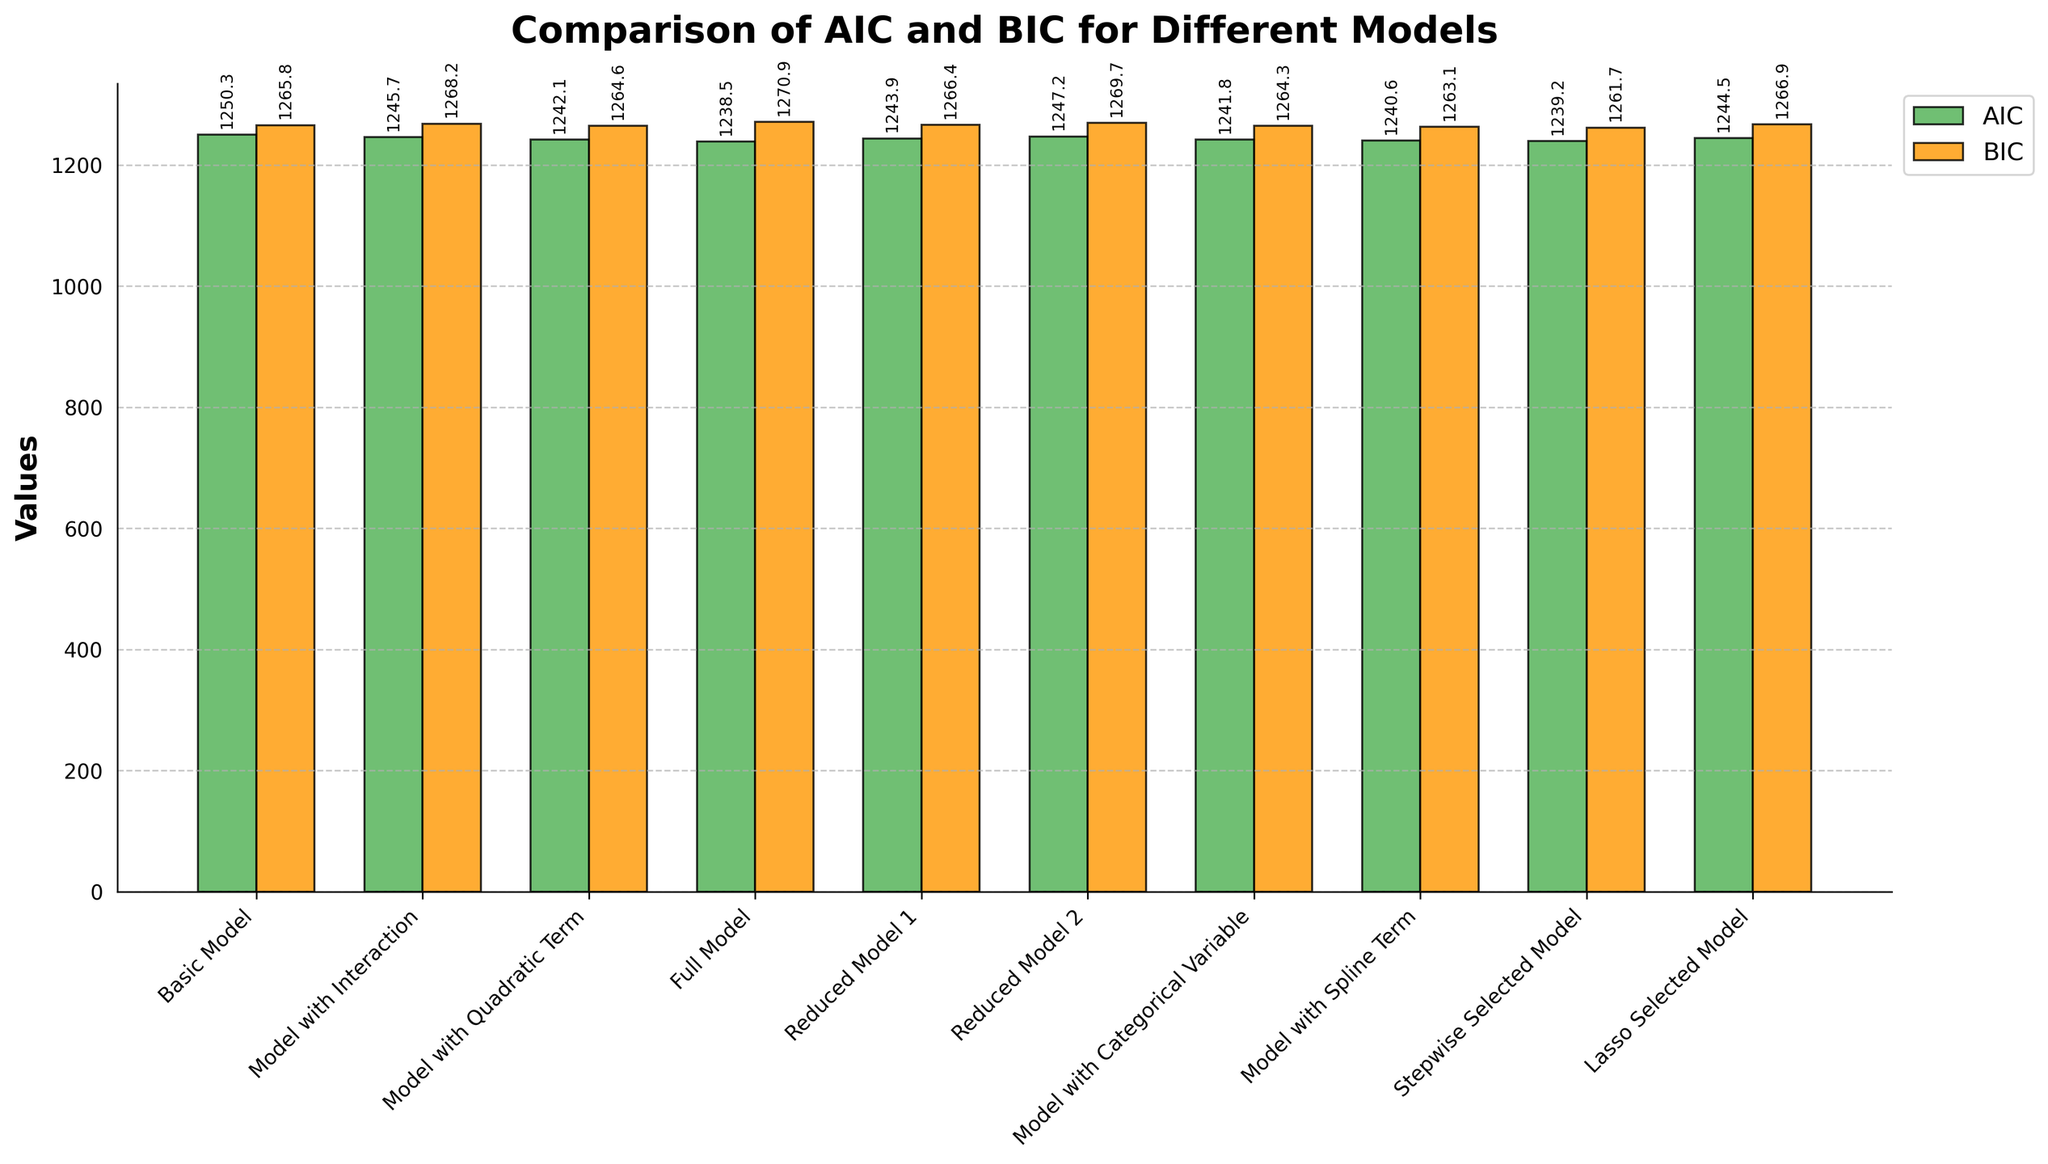What's the model with the lowest AIC value? The model with the lowest AIC can be identified by finding the shortest green bar in the bar chart, which pertains to the model with the Spline Term.
Answer: Model with Spline Term How much higher is the BIC value of the Full Model compared to its AIC value? To find the difference, compare the heights of the Full Model bars for AIC (orange) and BIC (green). The BIC is 1270.9 and AIC is 1238.5, so the difference is 1270.9 - 1238.5.
Answer: 32.4 Which model shows the smallest difference between AIC and BIC values? By examining the difference between AIC and BIC values for each model, the Basic Model, with AIC 1250.3 and BIC 1265.8, has the smallest difference of 1265.8 - 1250.3.
Answer: Basic Model Do any models have higher AIC values compared to their BIC values? By observing the bars, none of the models have AIC values higher than their BIC values; BIC bars (orange) are consistently taller or equal to AIC bars (green).
Answer: No Which model has the most significant difference between AIC and BIC values? Compare the differences for each model and note the one with the highest difference. The Full Model has the largest difference, with AIC 1238.5 and BIC 1270.9, so the difference is 1270.9 - 1238.5.
Answer: Full Model How many models have AIC values less than 1240? Count the green bars shorter than the value marking at 1240. Only the models called Full Model, Stepwise Selected Model, and Model with Spline Term fulfill this condition.
Answer: 3 models What is the highest BIC value across all models? Identify the tallest orange bar in the chart, which corresponds to BIC 1270.9 for the Full Model.
Answer: 1270.9 Compare the AIC values of the Model with Quadratic Term and Reduced Model 2; which is higher? By comparing the heights of their respective green bars, the AIC value of the Model with Quadratic Term (1242.1) is lower than Reduced Model 2 (1247.2).
Answer: Reduced Model 2 What is the average AIC value of the given models? Sum the AIC values and divide by the number of models: (1250.3 + 1245.7 + 1242.1 + 1238.5 + 1243.9 + 1247.2 + 1241.8 + 1240.6 + 1239.2 + 1244.5) / 10. The sum is 12433.8, and the average is 12433.8 / 10.
Answer: 1243.38 Which model has the second-lowest AIC value? The second shortest green bar, representing Stepwise Selected Model, with the second-lowest AIC value of 1239.2, follows the Model with Spline Term.
Answer: Stepwise Selected Model 